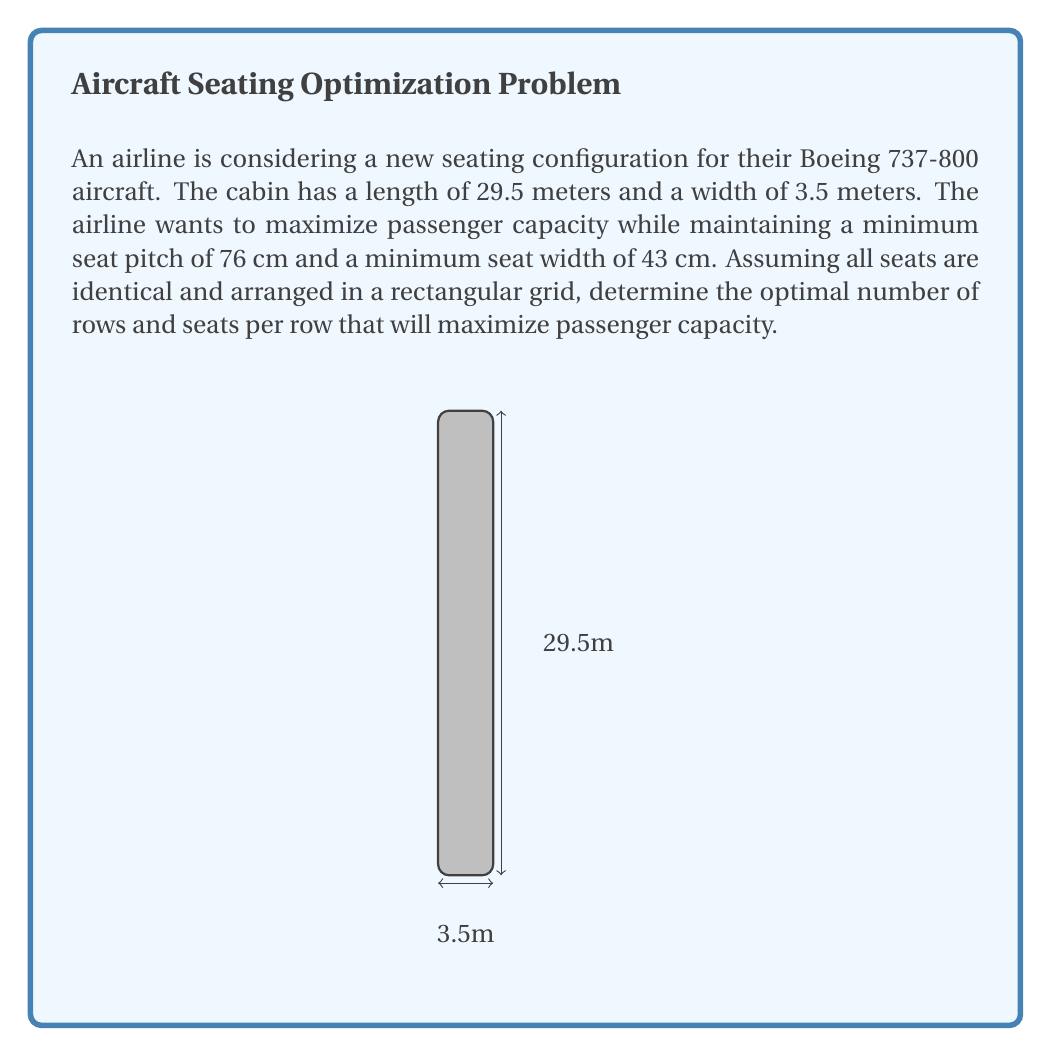What is the answer to this math problem? To solve this problem, we need to follow these steps:

1. Calculate the maximum number of rows:
   Maximum rows = $\lfloor \frac{\text{Cabin length}}{\text{Minimum seat pitch}} \rfloor$
   $$ \text{Max rows} = \left\lfloor \frac{2950 \text{ cm}}{76 \text{ cm}} \right\rfloor = 38 $$

2. Calculate the maximum number of seats per row:
   Maximum seats per row = $\lfloor \frac{\text{Cabin width}}{\text{Minimum seat width}} \rfloor$
   $$ \text{Max seats per row} = \left\lfloor \frac{350 \text{ cm}}{43 \text{ cm}} \right\rfloor = 8 $$

3. The total number of seats is the product of rows and seats per row:
   $$ \text{Total seats} = 38 \times 8 = 304 $$

4. Check if this configuration leaves enough space for aisles:
   Remaining width = $350 \text{ cm} - (8 \times 43 \text{ cm}) = 6 \text{ cm}$

   This is not enough space for aisles, so we need to reduce the number of seats per row.

5. Adjust the seats per row to allow for aisles:
   Let's try 6 seats per row:
   $$ 6 \times 43 \text{ cm} = 258 \text{ cm} $$
   Remaining width = $350 \text{ cm} - 258 \text{ cm} = 92 \text{ cm}$

   This leaves enough space for two aisles of 46 cm each, which is acceptable.

6. Calculate the final seating capacity:
   $$ \text{Total seats} = 38 \text{ rows} \times 6 \text{ seats per row} = 228 $$

Therefore, the optimal seating configuration is 38 rows with 6 seats per row, resulting in a total capacity of 228 passengers.
Answer: 38 rows, 6 seats per row, 228 total seats 